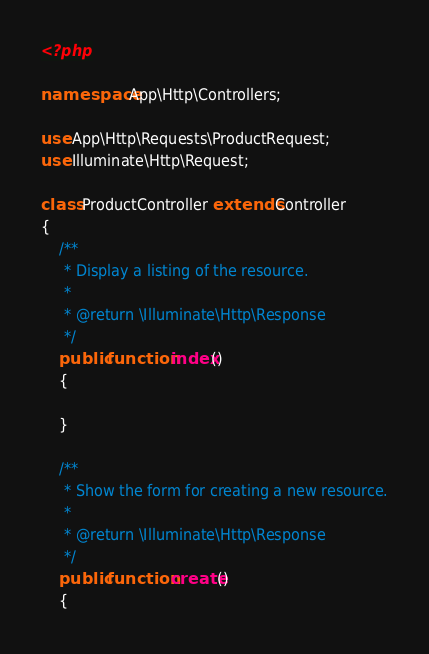<code> <loc_0><loc_0><loc_500><loc_500><_PHP_><?php

namespace App\Http\Controllers;

use App\Http\Requests\ProductRequest;
use Illuminate\Http\Request;

class ProductController extends Controller
{
    /**
     * Display a listing of the resource.
     *
     * @return \Illuminate\Http\Response
     */
    public function index()
    {
        
    }

    /**
     * Show the form for creating a new resource.
     *
     * @return \Illuminate\Http\Response
     */
    public function create()
    {</code> 